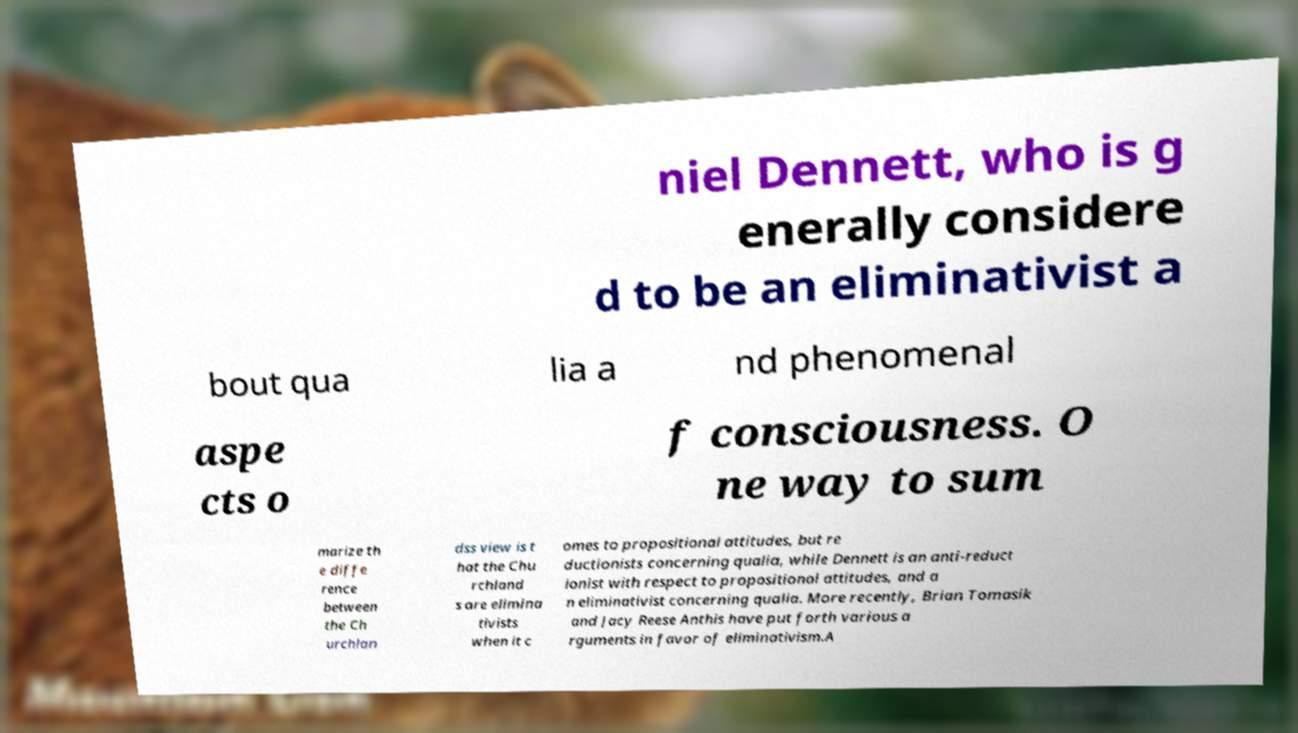Could you extract and type out the text from this image? niel Dennett, who is g enerally considere d to be an eliminativist a bout qua lia a nd phenomenal aspe cts o f consciousness. O ne way to sum marize th e diffe rence between the Ch urchlan dss view is t hat the Chu rchland s are elimina tivists when it c omes to propositional attitudes, but re ductionists concerning qualia, while Dennett is an anti-reduct ionist with respect to propositional attitudes, and a n eliminativist concerning qualia. More recently, Brian Tomasik and Jacy Reese Anthis have put forth various a rguments in favor of eliminativism.A 